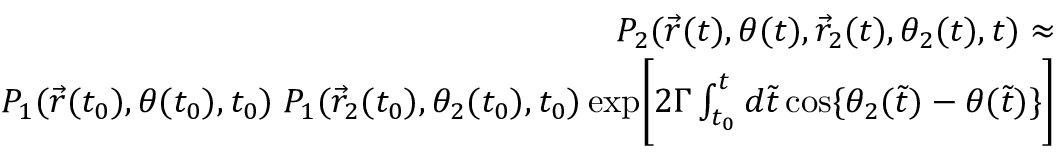<formula> <loc_0><loc_0><loc_500><loc_500>\begin{array} { r l r } & { P _ { 2 } ( \vec { r } ( t ) , \theta ( t ) , \vec { r } _ { 2 } ( t ) , \theta _ { 2 } ( t ) , t ) \approx } \\ & { P _ { 1 } ( \vec { r } ( t _ { 0 } ) , \theta ( t _ { 0 } ) , t _ { 0 } ) \, P _ { 1 } ( \vec { r } _ { 2 } ( t _ { 0 } ) , \theta _ { 2 } ( t _ { 0 } ) , t _ { 0 } ) \, e x p \left [ 2 \Gamma \int _ { t _ { 0 } } ^ { t } d \tilde { t } \, \cos \{ \theta _ { 2 } ( \tilde { t } ) - \theta ( \tilde { t } ) \} \right ] } \end{array}</formula> 